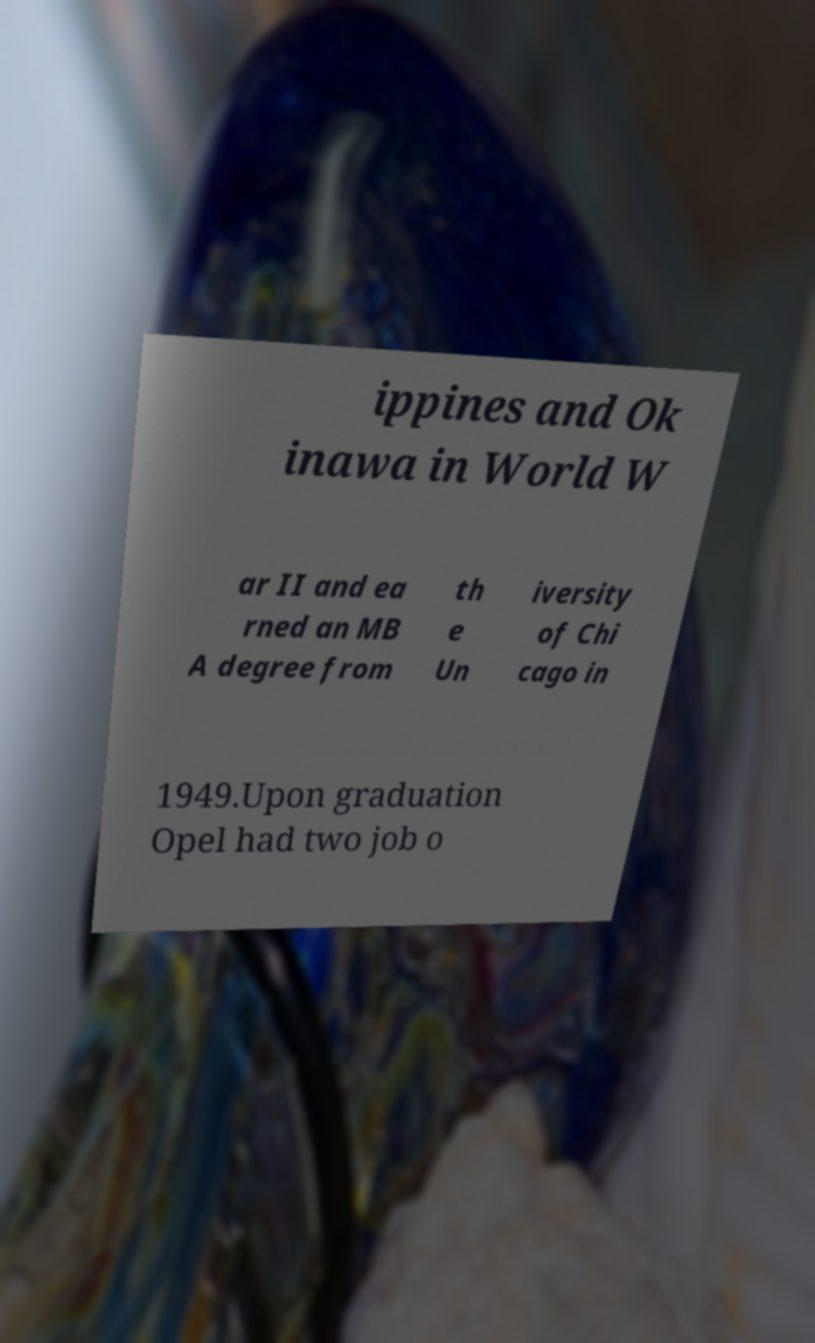I need the written content from this picture converted into text. Can you do that? ippines and Ok inawa in World W ar II and ea rned an MB A degree from th e Un iversity of Chi cago in 1949.Upon graduation Opel had two job o 